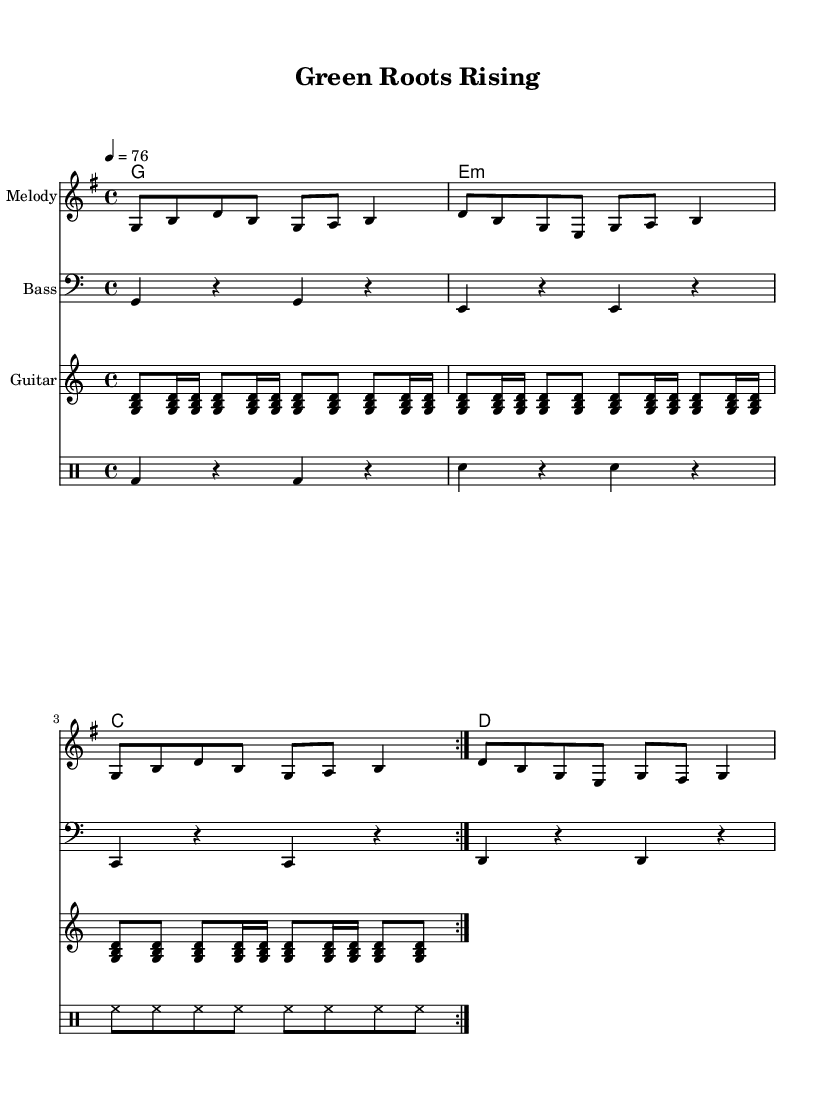What is the key signature of this music? The key signature is G major, which has one sharp (F#). This is determined by looking at the key signature at the beginning of the score, which indicates G major.
Answer: G major What is the time signature of this music? The time signature is 4/4, which means there are four beats in each measure and the quarter note gets one beat. This is indicated at the beginning of the score.
Answer: 4/4 What is the tempo of this music? The tempo is set to 76 beats per minute, as indicated by the marking. This provides the speed at which the piece should be played.
Answer: 76 How many measures are in the melody? The melody consists of four measures, which can be counted as each group of notes separated by vertical lines (bar lines) in the staff.
Answer: 4 What chord follows the E minor chord? The chord that follows the E minor chord is C major. This can be determined by looking at the chord progression in the chord names section.
Answer: C major What rhythmic pattern is played in the drums? The rhythmic pattern played in the drums primarily features a combination of bass drum and snare drum patterns punctuated by hi-hat hits, which is typical in reggae music. This is visible in the drummode section of the score.
Answer: Combination of bass drum, snare drum, and hi-hat 